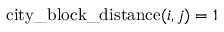Convert formula to latex. <formula><loc_0><loc_0><loc_500><loc_500>c i t y \_ b l o c k \_ d i s t a n c e ( i , j ) = 1</formula> 